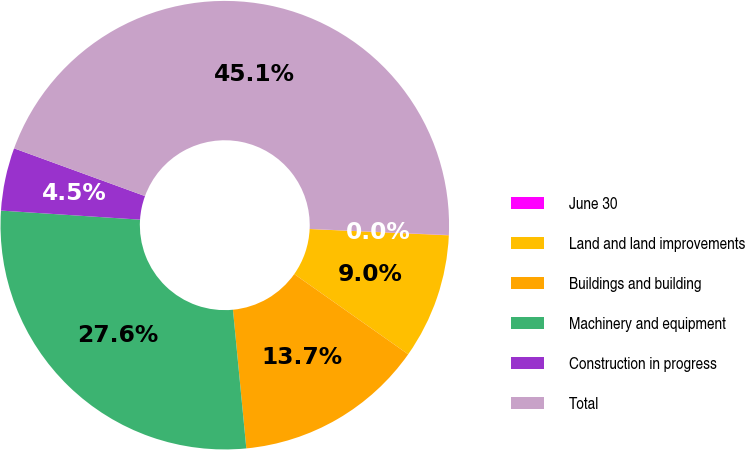Convert chart. <chart><loc_0><loc_0><loc_500><loc_500><pie_chart><fcel>June 30<fcel>Land and land improvements<fcel>Buildings and building<fcel>Machinery and equipment<fcel>Construction in progress<fcel>Total<nl><fcel>0.02%<fcel>9.04%<fcel>13.71%<fcel>27.57%<fcel>4.53%<fcel>45.14%<nl></chart> 